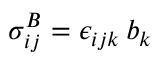Convert formula to latex. <formula><loc_0><loc_0><loc_500><loc_500>\sigma _ { i j } ^ { B } = \epsilon _ { i j k } \, b _ { k }</formula> 